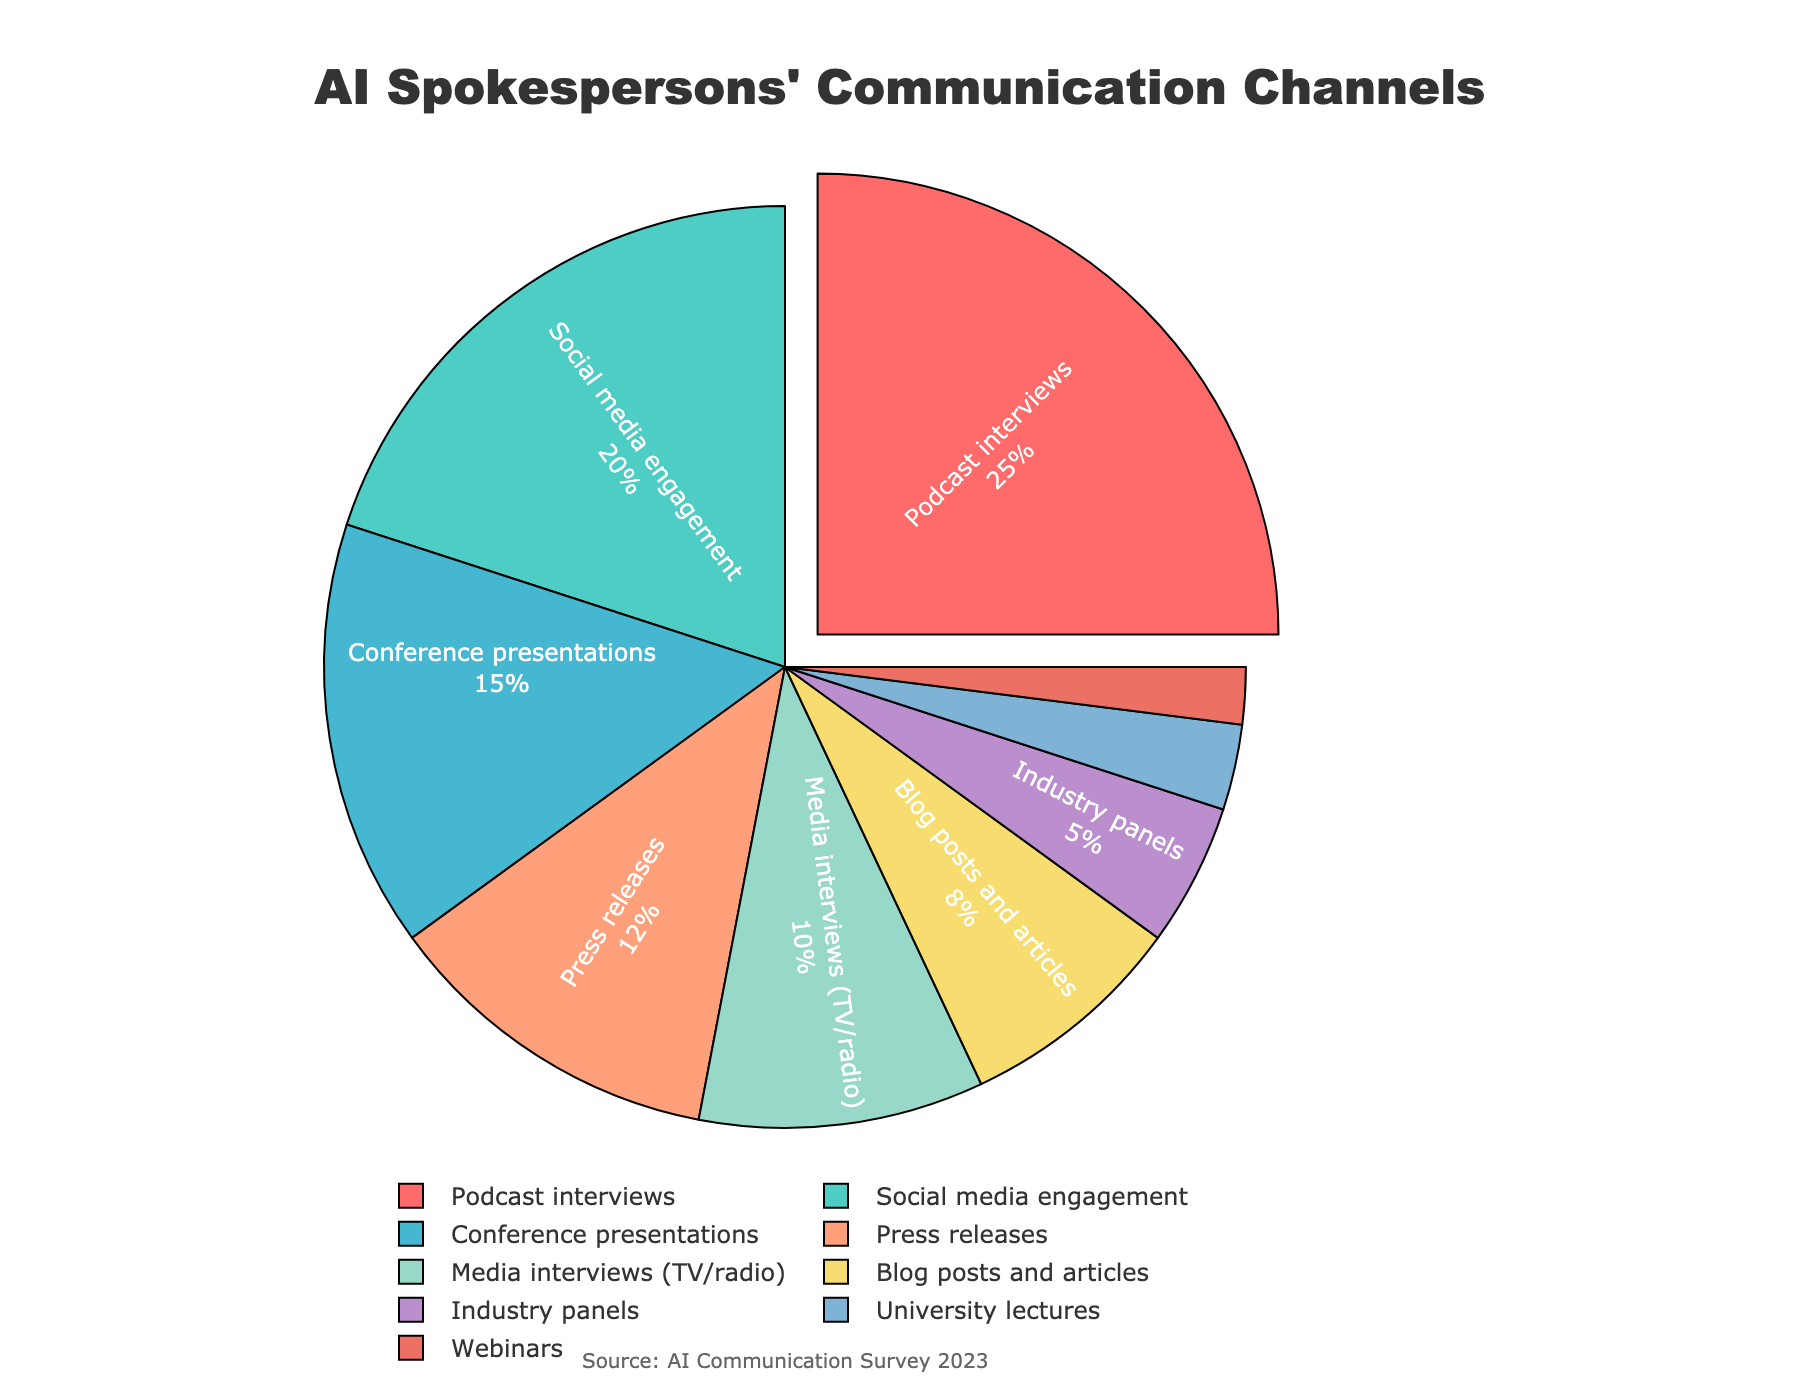What's the most time-consuming communication channel for AI spokespersons? The largest segment in the pie chart is pulled out, indicating the most significant proportion. The label shows that this segment represents podcast interviews, accounting for 25%.
Answer: Podcast interviews Which communication channel is engaged with the least? The smallest segment in the pie chart represents webinars, accounting for 2%.
Answer: Webinars How much more time is allocated to social media engagement compared to industry panels? The pie chart shows social media engagement at 20% and industry panels at 5%. The difference is 20% - 5% = 15%.
Answer: 15% What's the total percentage of time spent on conference presentations and press releases combined? The percentages for conference presentations and press releases are 15% and 12%, respectively. Adding these gives 15% + 12% = 27%.
Answer: 27% How does the time spent on blog posts and articles compare to media interviews (TV/radio)? The pie chart shows blog posts and articles at 8% and media interviews (TV/radio) at 10%. Media interviews (TV/radio) account for 2% more.
Answer: Media interviews (TV/radio) What’s the difference in allocated time between the top two communication channels? The top two channels are podcast interviews (25%) and social media engagement (20%). The difference is 25% - 20% = 5%.
Answer: 5% Which communication channels combined account for exactly 50% of the time? By inspection, podcast interviews (25%) and social media engagement (20%) add up to 45%, adding conference presentations (15%) exceeds 50%. Hence, the next combination: podcast interviews (25%) + social media engagement (20%) + media interviews (TV/radio) (10%) = 55% and the same with press releases (12%) = 57%. Therefore, a combination must be calculated by inspecting smaller contrib channels if legend sequencing altered. Here we only see clean addition as explained.
Answer: No exact 50% Is more time spent on conference presentations or press releases? The pie chart shows conference presentations at 15% and press releases at 12%. Conference presentations account for more time.
Answer: Conference presentations What is the combined percentage of time spent on communication channels that are below 10% individually? The channels below 10% are blog posts and articles (8%), industry panels (5%), university lectures (3%), and webinars (2%). Adding these gives 8% + 5% + 3% + 2% = 18%.
Answer: 18% If the percentage of time spent on university lectures doubled, would it exceed the time spent on press releases? Doubling the percentage for university lectures gives 3% * 2 = 6%. This does not exceed the 12% spent on press releases.
Answer: No 